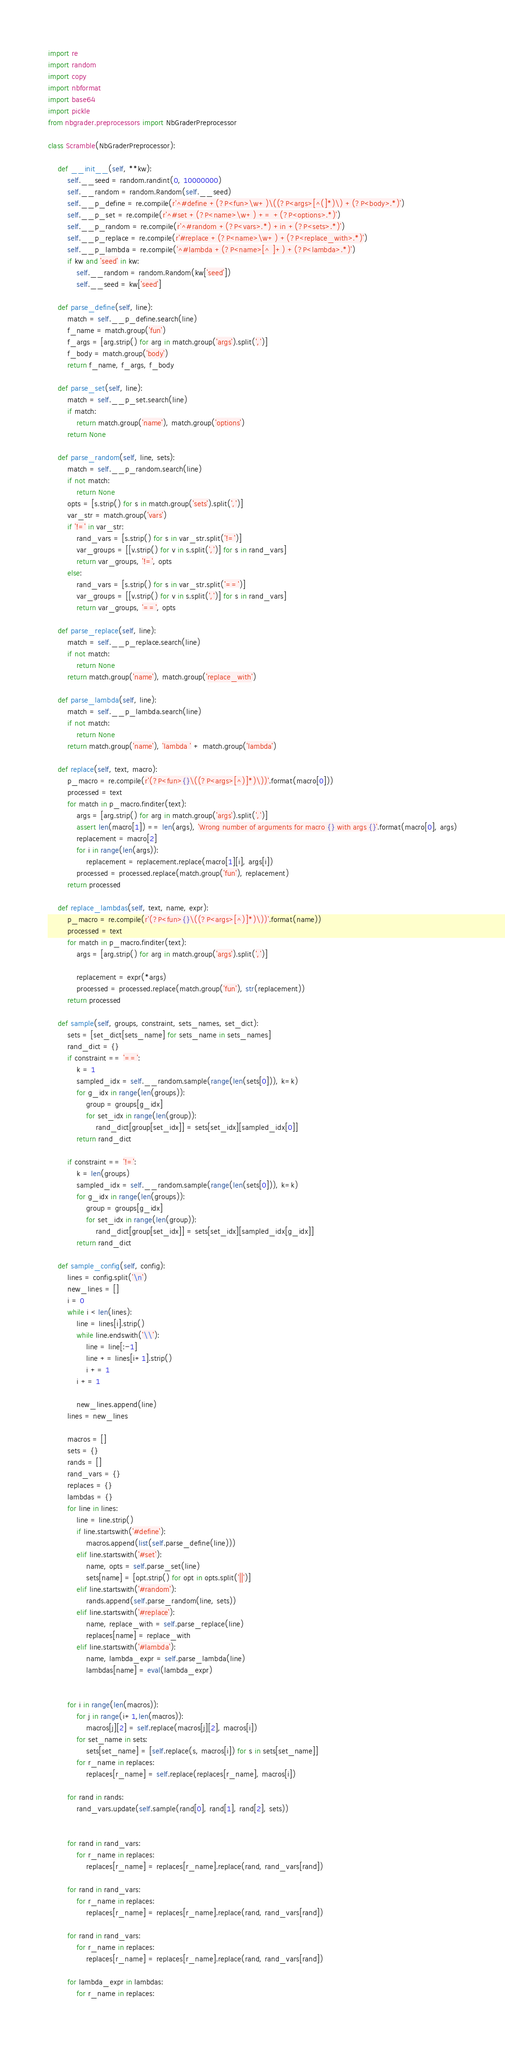Convert code to text. <code><loc_0><loc_0><loc_500><loc_500><_Python_>import re
import random
import copy
import nbformat
import base64
import pickle
from nbgrader.preprocessors import NbGraderPreprocessor

class Scramble(NbGraderPreprocessor):
    
    def __init__(self, **kw):
        self.__seed = random.randint(0, 10000000)
        self.__random = random.Random(self.__seed)
        self.__p_define = re.compile(r'^#define +(?P<fun>\w+)\((?P<args>[^(]*)\) +(?P<body>.*)')
        self.__p_set = re.compile(r'^#set +(?P<name>\w+) += +(?P<options>.*)')
        self.__p_random = re.compile(r'^#random +(?P<vars>.*) +in +(?P<sets>.*)')
        self.__p_replace = re.compile(r'#replace +(?P<name>\w+) +(?P<replace_with>.*)')
        self.__p_lambda = re.compile('^#lambda +(?P<name>[^ ]+) +(?P<lambda>.*)')
        if kw and 'seed' in kw:
            self.__random = random.Random(kw['seed'])
            self.__seed = kw['seed']

    def parse_define(self, line):
        match = self.__p_define.search(line)
        f_name = match.group('fun')
        f_args = [arg.strip() for arg in match.group('args').split(',')]
        f_body = match.group('body')
        return f_name, f_args, f_body

    def parse_set(self, line):
        match = self.__p_set.search(line)
        if match:
            return match.group('name'), match.group('options')
        return None

    def parse_random(self, line, sets):
        match = self.__p_random.search(line)
        if not match:
            return None
        opts = [s.strip() for s in match.group('sets').split(',')]
        var_str = match.group('vars')
        if '!=' in var_str:
            rand_vars = [s.strip() for s in var_str.split('!=')]
            var_groups = [[v.strip() for v in s.split(',')] for s in rand_vars]
            return var_groups, '!=', opts
        else:
            rand_vars = [s.strip() for s in var_str.split('==')]
            var_groups = [[v.strip() for v in s.split(',')] for s in rand_vars]
            return var_groups, '==', opts
        
    def parse_replace(self, line):
        match = self.__p_replace.search(line)
        if not match:
            return None
        return match.group('name'), match.group('replace_with')
    
    def parse_lambda(self, line):
        match = self.__p_lambda.search(line)
        if not match:
            return None
        return match.group('name'), 'lambda ' + match.group('lambda')
    
    def replace(self, text, macro):
        p_macro = re.compile(r'(?P<fun>{}\((?P<args>[^)]*)\))'.format(macro[0]))
        processed = text
        for match in p_macro.finditer(text):
            args = [arg.strip() for arg in match.group('args').split(',')]
            assert len(macro[1]) == len(args), 'Wrong number of arguments for macro {} with args {}'.format(macro[0], args)
            replacement = macro[2]
            for i in range(len(args)):
                replacement = replacement.replace(macro[1][i], args[i])
            processed = processed.replace(match.group('fun'), replacement)
        return processed
    
    def replace_lambdas(self, text, name, expr):
        p_macro = re.compile(r'(?P<fun>{}\((?P<args>[^)]*)\))'.format(name))
        processed = text
        for match in p_macro.finditer(text):
            args = [arg.strip() for arg in match.group('args').split(',')]
    
            replacement = expr(*args)
            processed = processed.replace(match.group('fun'), str(replacement))
        return processed

    def sample(self, groups, constraint, sets_names, set_dict):
        sets = [set_dict[sets_name] for sets_name in sets_names]
        rand_dict = {}
        if constraint == '==':
            k = 1
            sampled_idx = self.__random.sample(range(len(sets[0])), k=k)
            for g_idx in range(len(groups)):
                group = groups[g_idx]
                for set_idx in range(len(group)):
                    rand_dict[group[set_idx]] = sets[set_idx][sampled_idx[0]]
            return rand_dict        

        if constraint == '!=':
            k = len(groups)
            sampled_idx = self.__random.sample(range(len(sets[0])), k=k)
            for g_idx in range(len(groups)):
                group = groups[g_idx]
                for set_idx in range(len(group)):
                    rand_dict[group[set_idx]] = sets[set_idx][sampled_idx[g_idx]]
            return rand_dict

    def sample_config(self, config):      
        lines = config.split('\n')
        new_lines = []
        i = 0
        while i < len(lines):
            line = lines[i].strip()
            while line.endswith('\\'):
                line = line[:-1]
                line += lines[i+1].strip()
                i += 1
            i += 1

            new_lines.append(line)
        lines = new_lines

        macros = []
        sets = {}
        rands = []
        rand_vars = {}
        replaces = {}
        lambdas = {}
        for line in lines:
            line = line.strip()
            if line.startswith('#define'):
                macros.append(list(self.parse_define(line)))
            elif line.startswith('#set'):
                name, opts = self.parse_set(line)
                sets[name] = [opt.strip() for opt in opts.split('||')]
            elif line.startswith('#random'):
                rands.append(self.parse_random(line, sets))
            elif line.startswith('#replace'):
                name, replace_with = self.parse_replace(line)
                replaces[name] = replace_with
            elif line.startswith('#lambda'):
                name, lambda_expr = self.parse_lambda(line)
                lambdas[name] = eval(lambda_expr)


        for i in range(len(macros)):
            for j in range(i+1,len(macros)):
                macros[j][2] = self.replace(macros[j][2], macros[i])
            for set_name in sets:
                sets[set_name] = [self.replace(s, macros[i]) for s in sets[set_name]]
            for r_name in replaces:
                replaces[r_name] = self.replace(replaces[r_name], macros[i])

        for rand in rands:
            rand_vars.update(self.sample(rand[0], rand[1], rand[2], sets))


        for rand in rand_vars:
            for r_name in replaces:
                replaces[r_name] = replaces[r_name].replace(rand, rand_vars[rand])

        for rand in rand_vars:
            for r_name in replaces:
                replaces[r_name] = replaces[r_name].replace(rand, rand_vars[rand])
                
        for rand in rand_vars:
            for r_name in replaces:
                replaces[r_name] = replaces[r_name].replace(rand, rand_vars[rand])
                
        for lambda_expr in lambdas:
            for r_name in replaces:</code> 